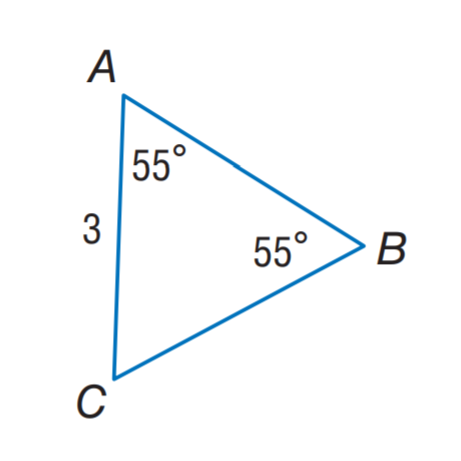Question: Find C B.
Choices:
A. 2
B. 3
C. 4
D. 55
Answer with the letter. Answer: B 